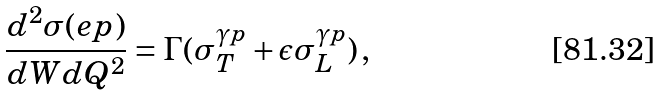Convert formula to latex. <formula><loc_0><loc_0><loc_500><loc_500>\frac { d ^ { 2 } \sigma ( e p ) } { d W d Q ^ { 2 } } = \Gamma ( \sigma _ { T } ^ { \gamma p } + \epsilon \sigma _ { L } ^ { \gamma p } ) \, ,</formula> 